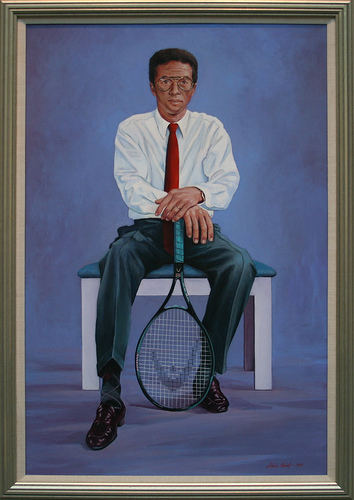Please provide a short description for this region: [0.42, 0.48, 0.58, 0.83]. A man is holding a blue tennis racket. 